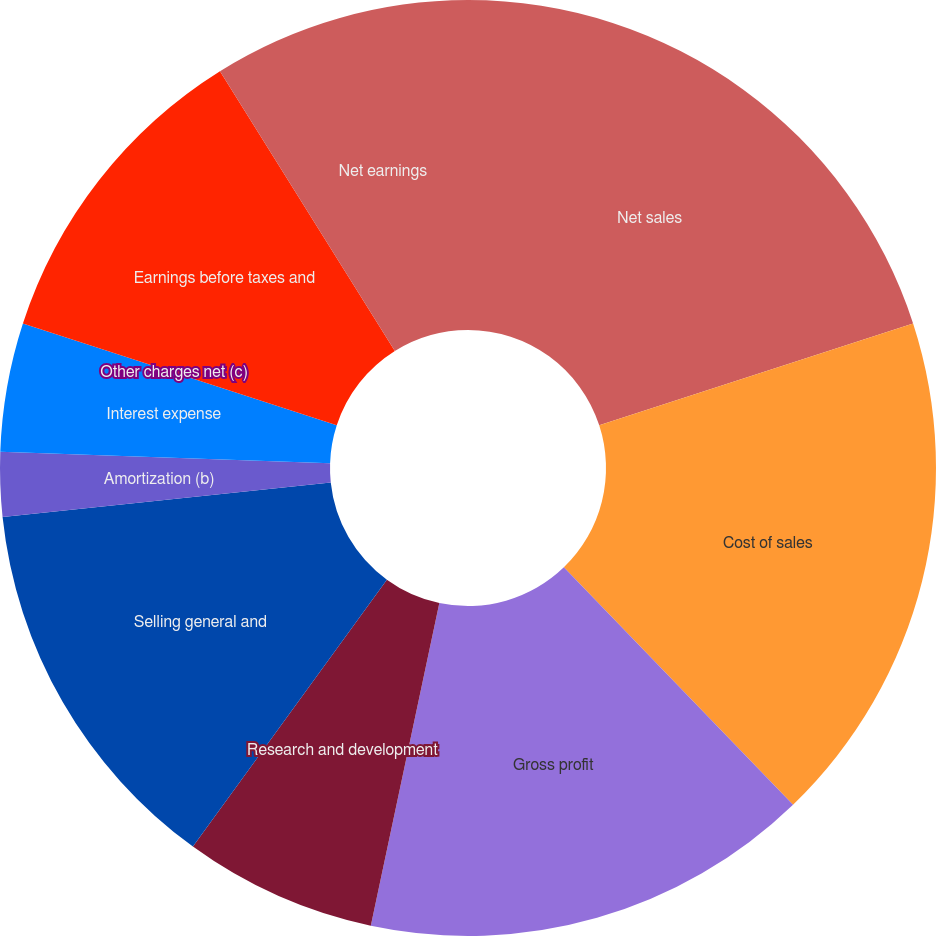Convert chart to OTSL. <chart><loc_0><loc_0><loc_500><loc_500><pie_chart><fcel>Net sales<fcel>Cost of sales<fcel>Gross profit<fcel>Research and development<fcel>Selling general and<fcel>Amortization (b)<fcel>Interest expense<fcel>Other charges net (c)<fcel>Earnings before taxes and<fcel>Net earnings<nl><fcel>20.0%<fcel>17.78%<fcel>15.55%<fcel>6.67%<fcel>13.33%<fcel>2.22%<fcel>4.45%<fcel>0.0%<fcel>11.11%<fcel>8.89%<nl></chart> 